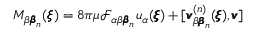<formula> <loc_0><loc_0><loc_500><loc_500>M _ { \beta { \pm b \beta } _ { n } } ( { \pm b \xi } ) = 8 \pi \mu \mathcal { F } _ { \alpha \beta { \pm b \beta } _ { n } } u _ { \alpha } ( { \pm b \xi } ) + [ { \pm b v } _ { \beta { \pm b \beta } _ { n } } ^ { ( n ) } ( { \pm b \xi } ) , { \pm b v } ]</formula> 